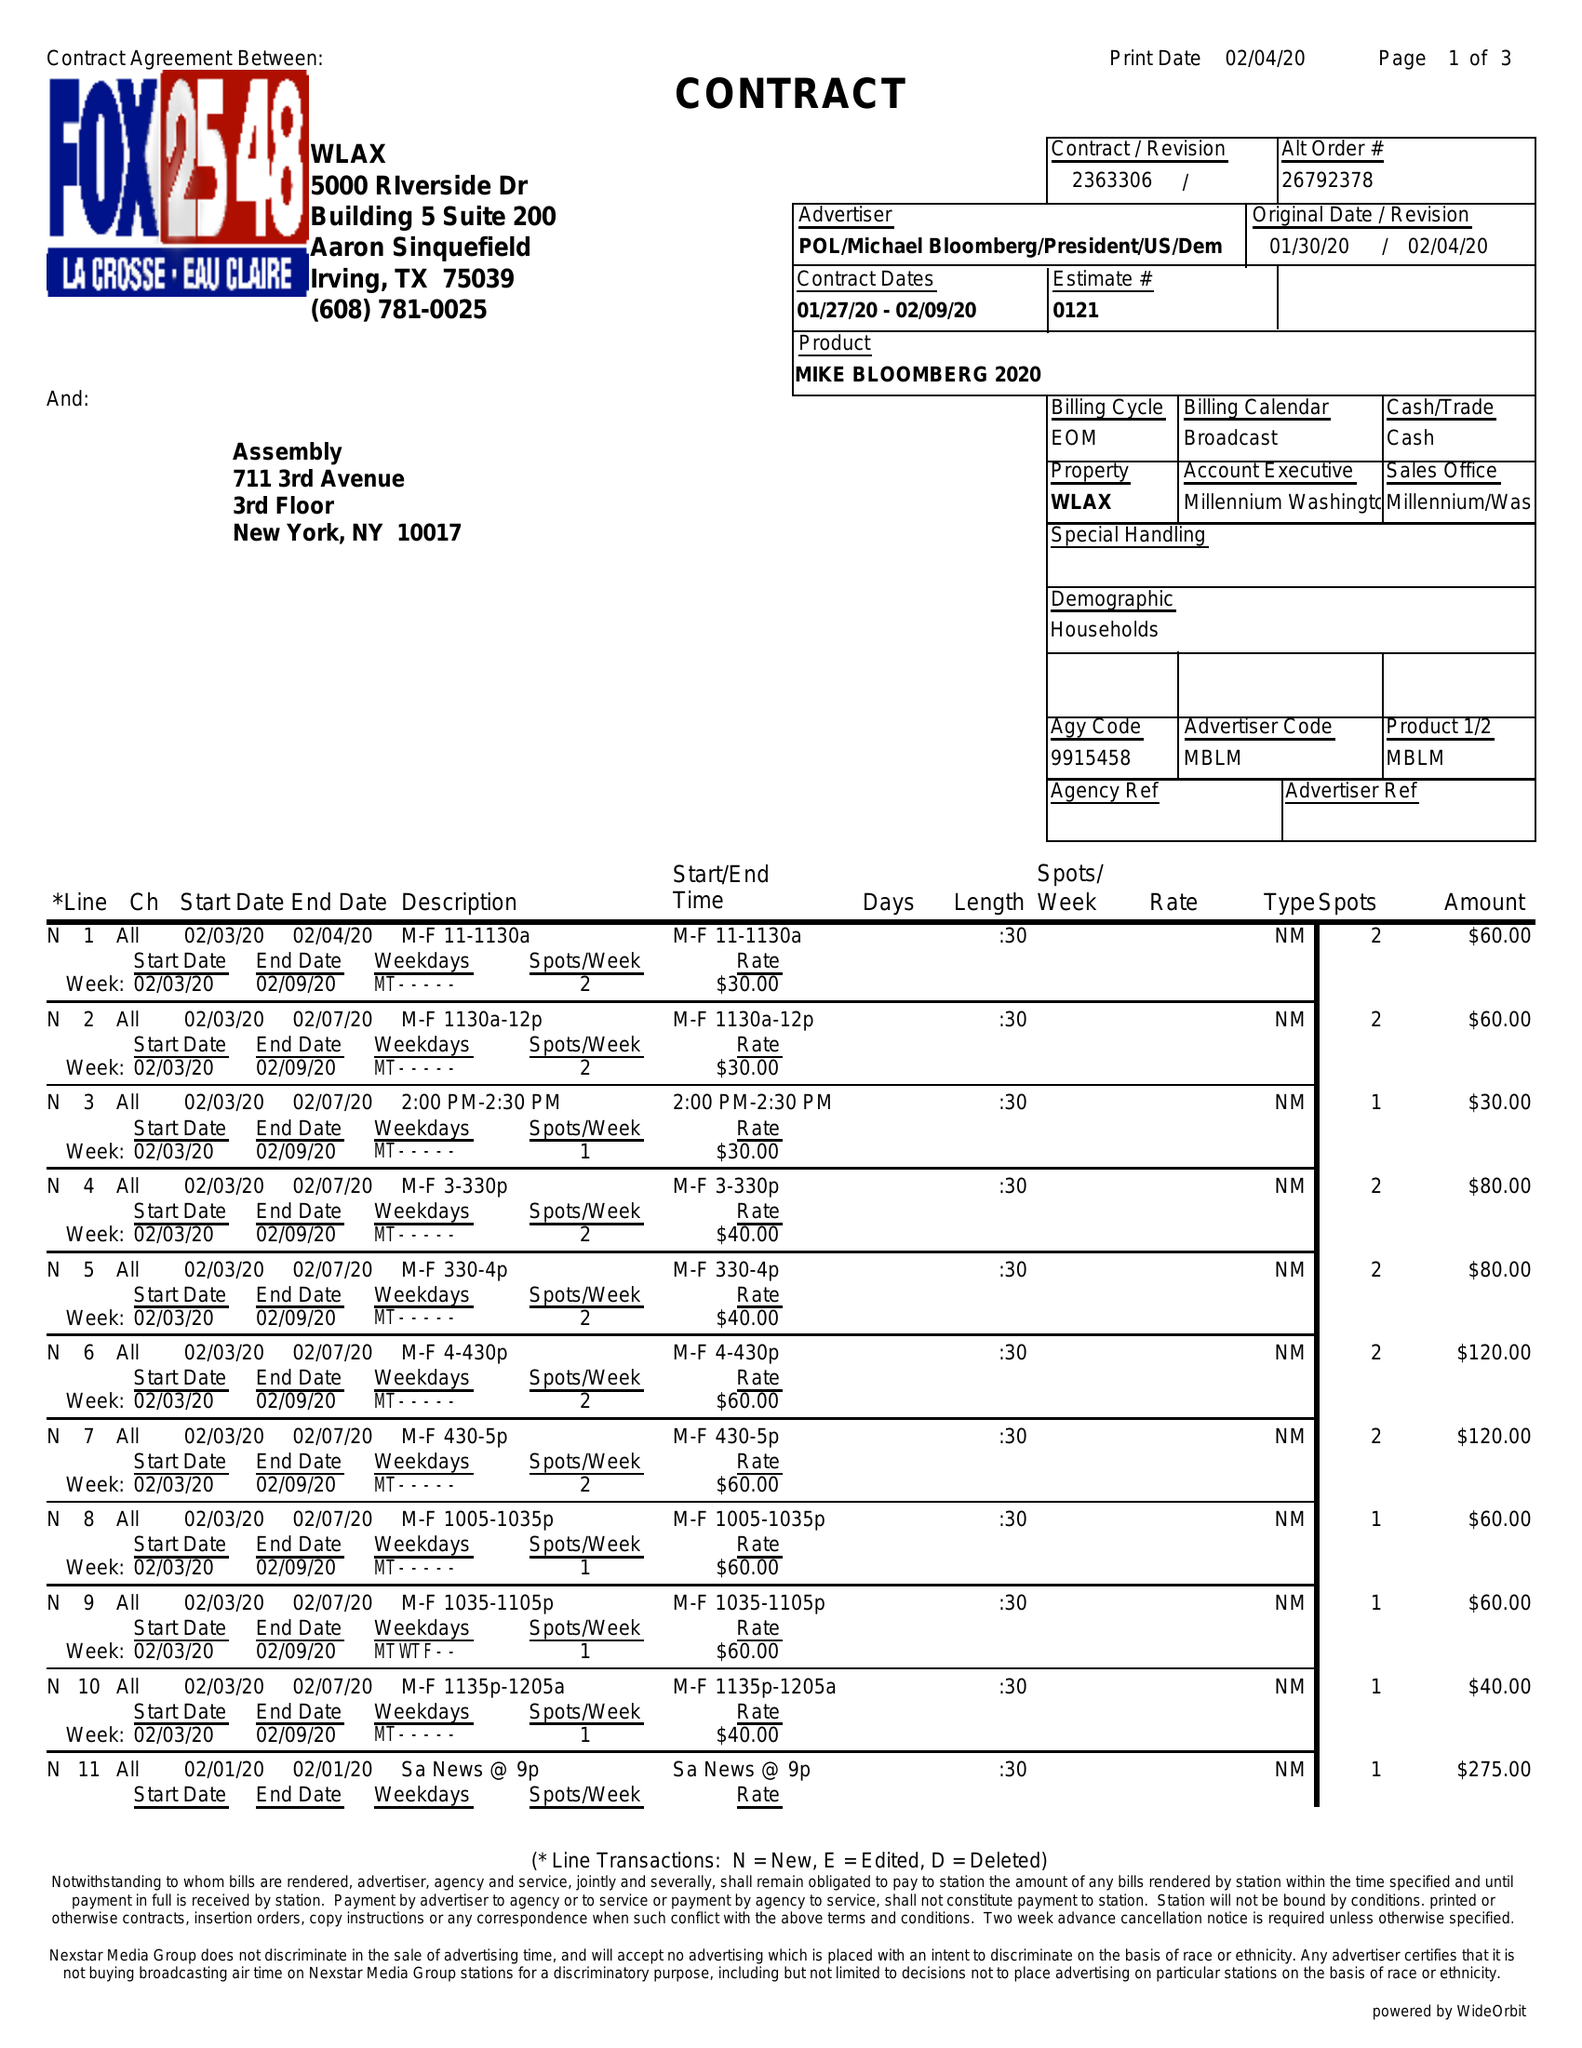What is the value for the flight_from?
Answer the question using a single word or phrase. 01/27/20 